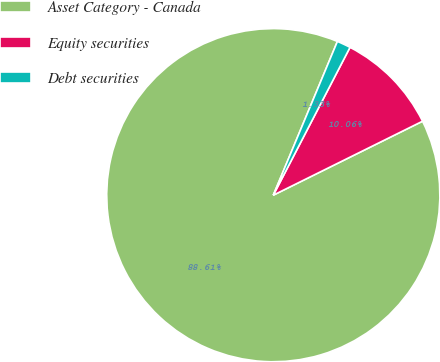Convert chart. <chart><loc_0><loc_0><loc_500><loc_500><pie_chart><fcel>Asset Category - Canada<fcel>Equity securities<fcel>Debt securities<nl><fcel>88.62%<fcel>10.06%<fcel>1.33%<nl></chart> 